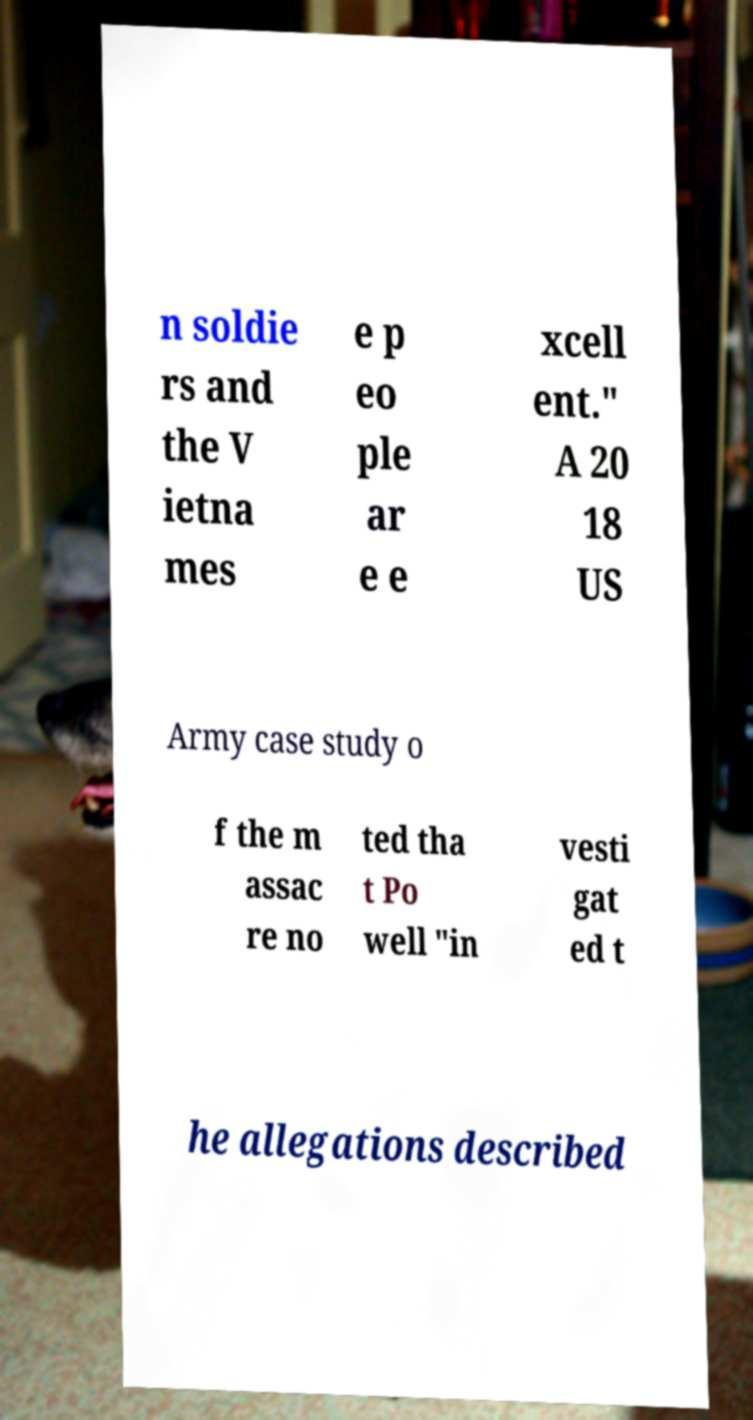For documentation purposes, I need the text within this image transcribed. Could you provide that? n soldie rs and the V ietna mes e p eo ple ar e e xcell ent." A 20 18 US Army case study o f the m assac re no ted tha t Po well "in vesti gat ed t he allegations described 